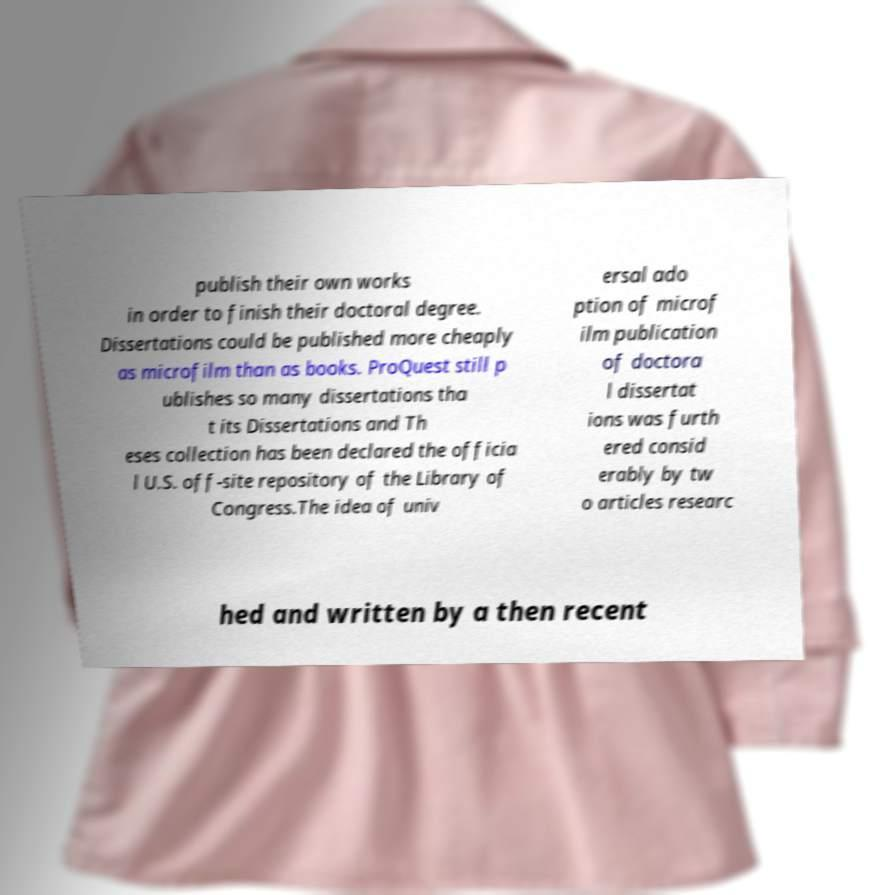There's text embedded in this image that I need extracted. Can you transcribe it verbatim? publish their own works in order to finish their doctoral degree. Dissertations could be published more cheaply as microfilm than as books. ProQuest still p ublishes so many dissertations tha t its Dissertations and Th eses collection has been declared the officia l U.S. off-site repository of the Library of Congress.The idea of univ ersal ado ption of microf ilm publication of doctora l dissertat ions was furth ered consid erably by tw o articles researc hed and written by a then recent 